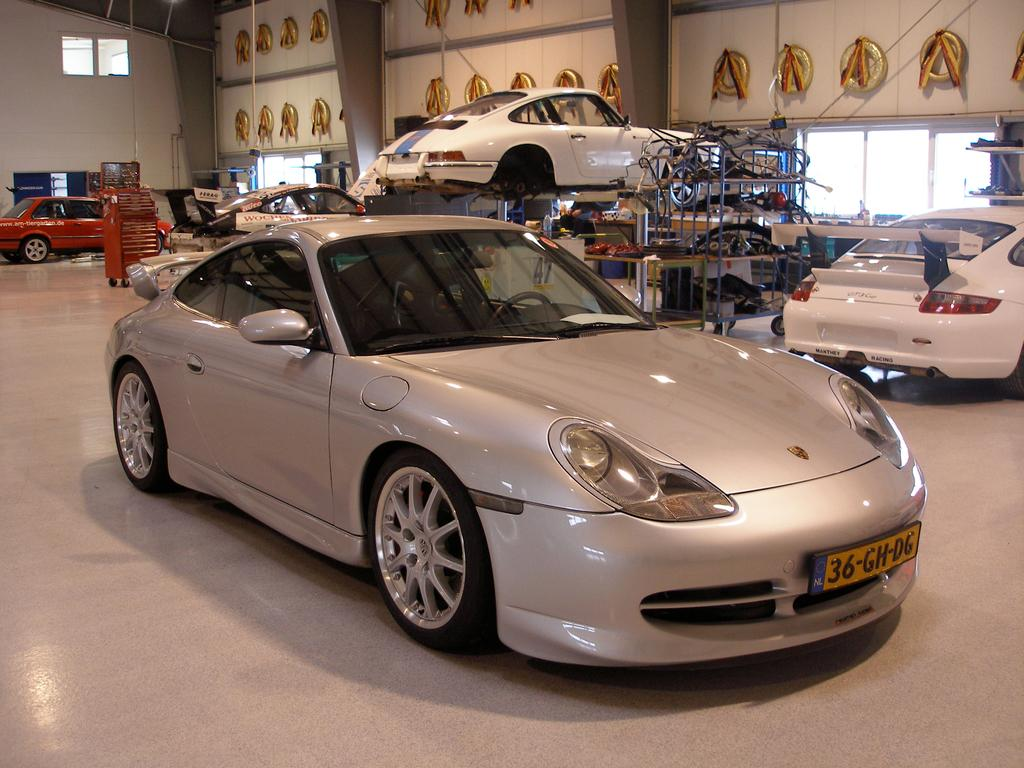What objects are on the floor in the image? There are cars on the floor in the image. What structure can be seen in the image? There is a rack in the image. What can be seen in the background of the image? There are windows and a wall in the background of the image. Can you describe the objects visible in the background of the image? There are some objects visible in the background of the image, but their specific details are not mentioned in the provided facts. What song is being played by the cars in the image? There is no indication in the image that the cars are playing a song, as cars typically do not have the ability to play music. 